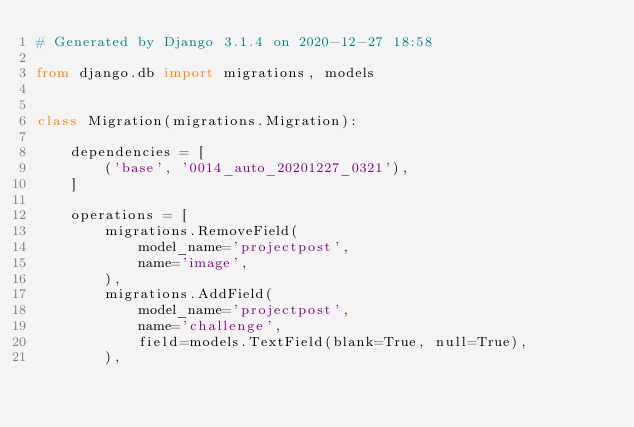<code> <loc_0><loc_0><loc_500><loc_500><_Python_># Generated by Django 3.1.4 on 2020-12-27 18:58

from django.db import migrations, models


class Migration(migrations.Migration):

    dependencies = [
        ('base', '0014_auto_20201227_0321'),
    ]

    operations = [
        migrations.RemoveField(
            model_name='projectpost',
            name='image',
        ),
        migrations.AddField(
            model_name='projectpost',
            name='challenge',
            field=models.TextField(blank=True, null=True),
        ),</code> 